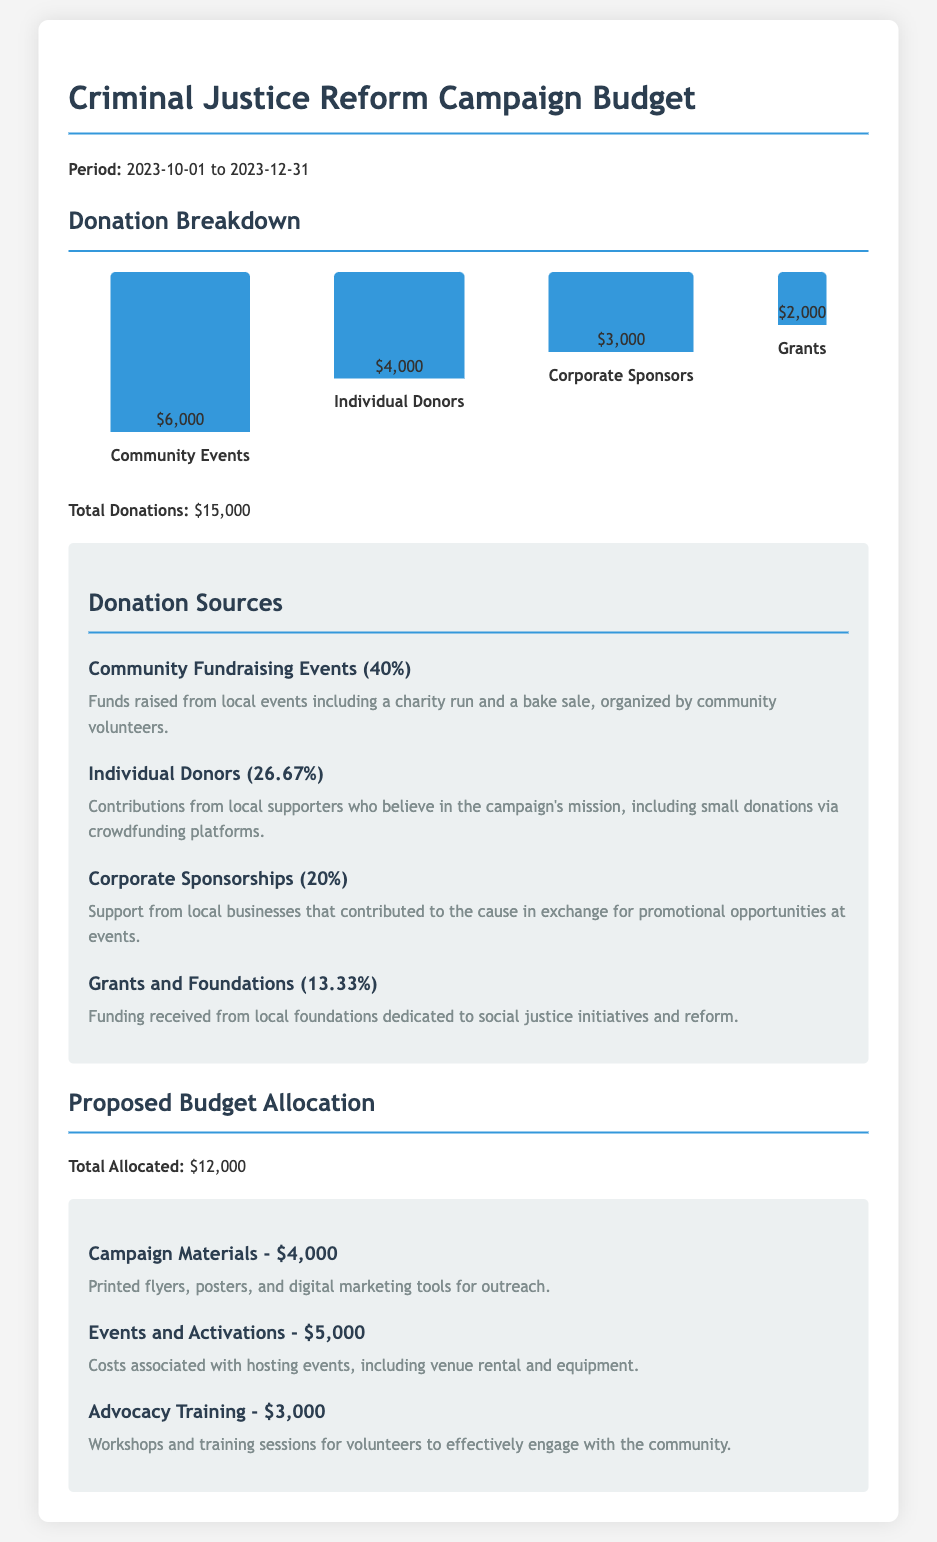What is the total amount of donations received? The total donations are explicitly stated as $15,000 in the document.
Answer: $15,000 What percentage of donations came from Community Fundraising Events? The document states that 40% of donations were from Community Fundraising Events.
Answer: 40% How much money was raised from Individual Donors? Individual Donors contributed $4,000, as noted in the donation breakdown.
Answer: $4,000 What is the allocated amount for Campaign Materials? The budget specifies that $4,000 is allocated for Campaign Materials.
Answer: $4,000 What type of events helped raise the most money? Community Events generated the highest amount of donations, totaling $6,000.
Answer: Community Events Which category received the least amount of donations? Grants received the least with a total of $2,000, making it the lowest in the donation breakdown.
Answer: Grants How much did Corporate Sponsors contribute? Corporate Sponsors provided $3,000, as listed in the donation breakdown.
Answer: $3,000 What is the total allocated budget for Events and Activations? The document indicates that $5,000 is allocated for Events and Activations.
Answer: $5,000 What type of funding falls under Grants and Foundations? Funding from local foundations dedicated to social justice initiatives is classified under Grants.
Answer: Grants and Foundations 